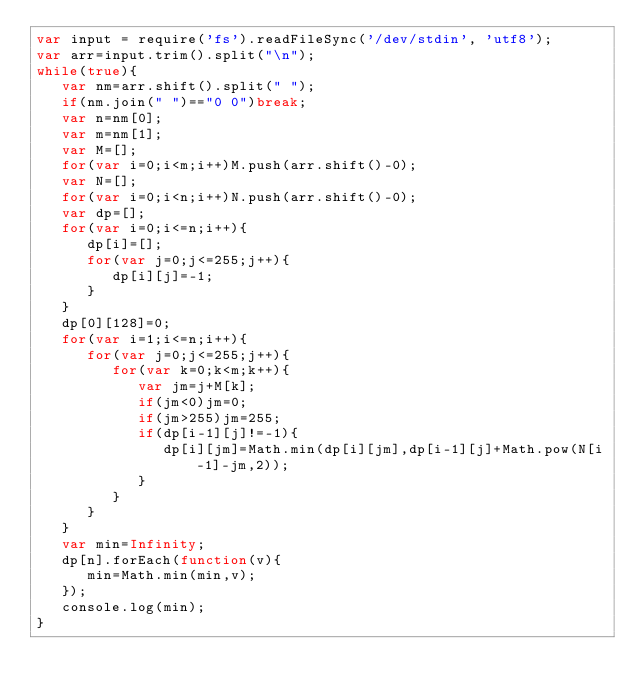<code> <loc_0><loc_0><loc_500><loc_500><_JavaScript_>var input = require('fs').readFileSync('/dev/stdin', 'utf8');
var arr=input.trim().split("\n");
while(true){
   var nm=arr.shift().split(" ");
   if(nm.join(" ")=="0 0")break;
   var n=nm[0];
   var m=nm[1];
   var M=[];
   for(var i=0;i<m;i++)M.push(arr.shift()-0);
   var N=[];
   for(var i=0;i<n;i++)N.push(arr.shift()-0);
   var dp=[];
   for(var i=0;i<=n;i++){
      dp[i]=[];
      for(var j=0;j<=255;j++){
         dp[i][j]=-1;
      }
   }
   dp[0][128]=0;
   for(var i=1;i<=n;i++){
      for(var j=0;j<=255;j++){
         for(var k=0;k<m;k++){
            var jm=j+M[k];
            if(jm<0)jm=0;
            if(jm>255)jm=255;
            if(dp[i-1][j]!=-1){
               dp[i][jm]=Math.min(dp[i][jm],dp[i-1][j]+Math.pow(N[i-1]-jm,2));
            }
         }
      }
   }
   var min=Infinity;
   dp[n].forEach(function(v){
      min=Math.min(min,v);
   });
   console.log(min);
}</code> 